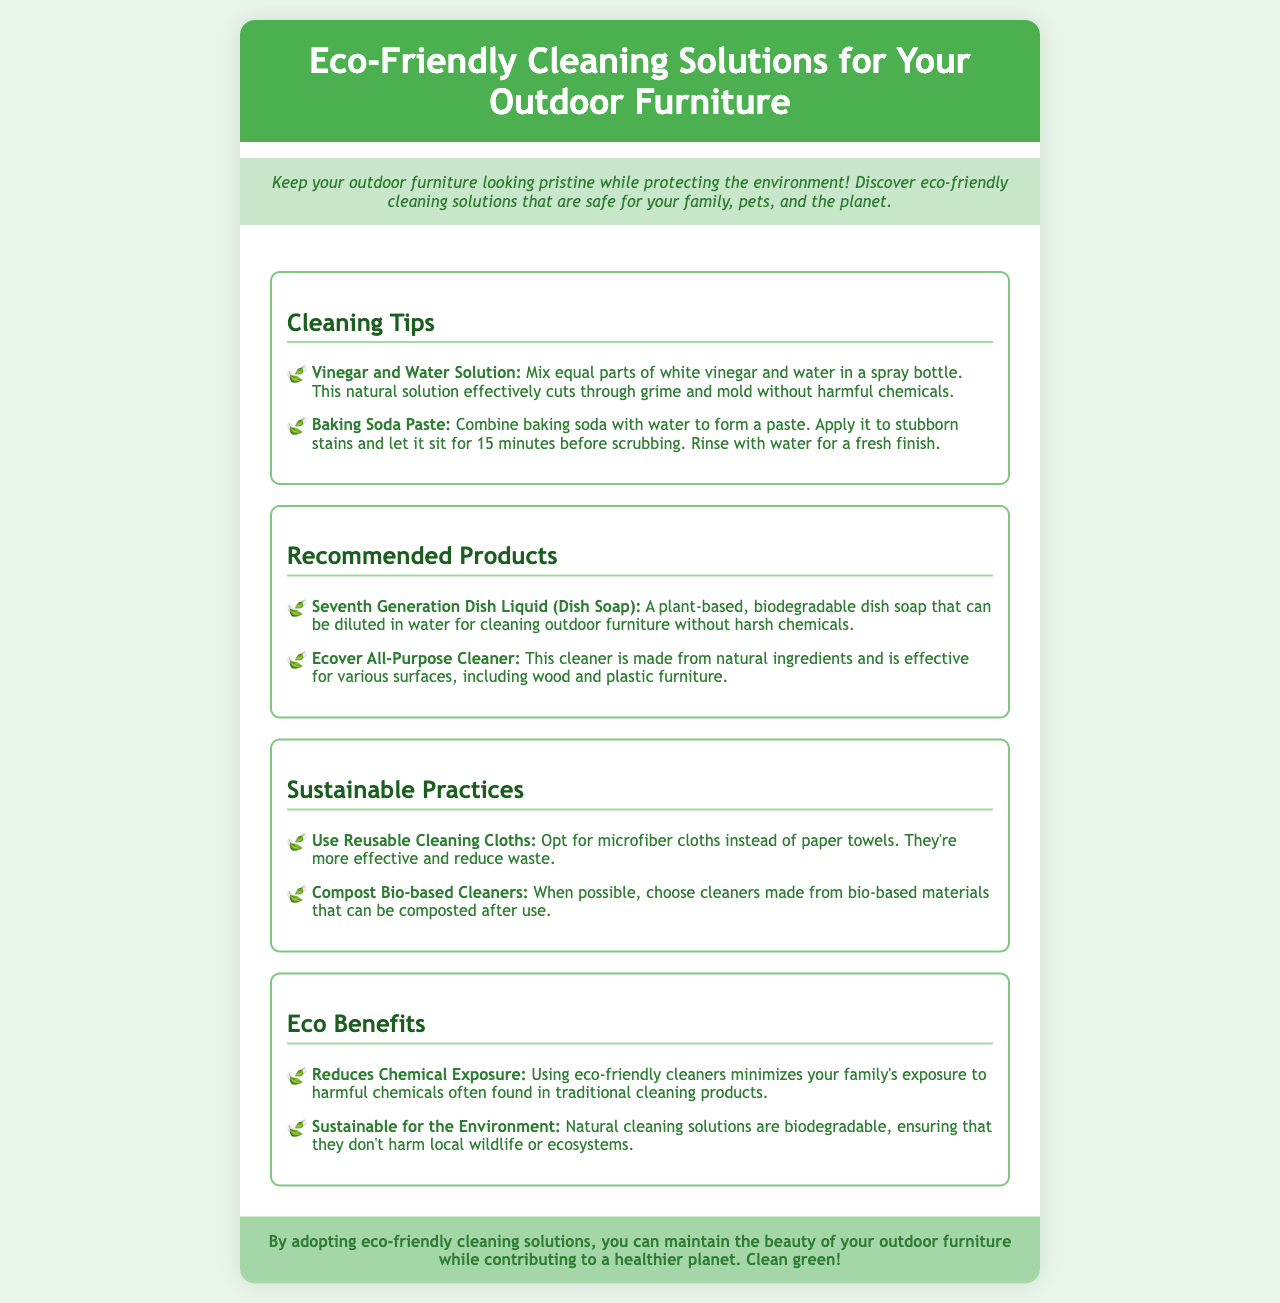What are the two main ingredients in the vinegar solution? The document states that the vinegar solution is made with equal parts of white vinegar and water.
Answer: white vinegar and water What is a recommended dish soap mentioned? The document lists Seventh Generation Dish Liquid as a recommended product.
Answer: Seventh Generation Dish Liquid What should you apply baking soda with to remove stains? The document indicates that you should combine baking soda with water to form a paste.
Answer: water What is a sustainable cleaning practice suggested? The brochure recommends using microfiber cloths instead of paper towels.
Answer: Reusable Cleaning Cloths What benefit do eco-friendly cleaners provide according to the document? The document mentions that eco-friendly cleaners reduce chemical exposure for families.
Answer: Reduces Chemical Exposure Which cleaner is made from natural ingredients for various surfaces? The document identifies Ecover All-Purpose Cleaner as effective for multiple surfaces.
Answer: Ecover All-Purpose Cleaner How long should baking soda paste sit on stubborn stains? The document specifies to let the baking soda paste sit for 15 minutes before scrubbing.
Answer: 15 minutes What kind of waste do reusable cloths help reduce? The document highlights that using microfiber cloths helps reduce waste compared to paper towels.
Answer: Waste What is the main focus of the brochure? The main focus of the brochure is to provide eco-friendly cleaning solutions for outdoor furniture.
Answer: Eco-Friendly Cleaning Solutions 